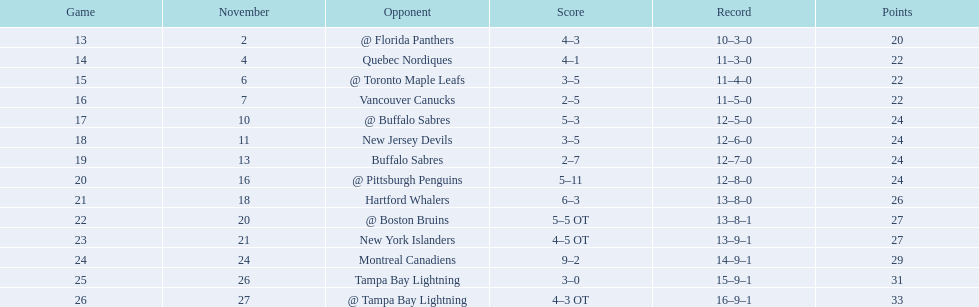What are the teams in the atlantic division? Quebec Nordiques, Vancouver Canucks, New Jersey Devils, Buffalo Sabres, Hartford Whalers, New York Islanders, Montreal Canadiens, Tampa Bay Lightning. Which of those scored fewer points than the philadelphia flyers? Tampa Bay Lightning. 